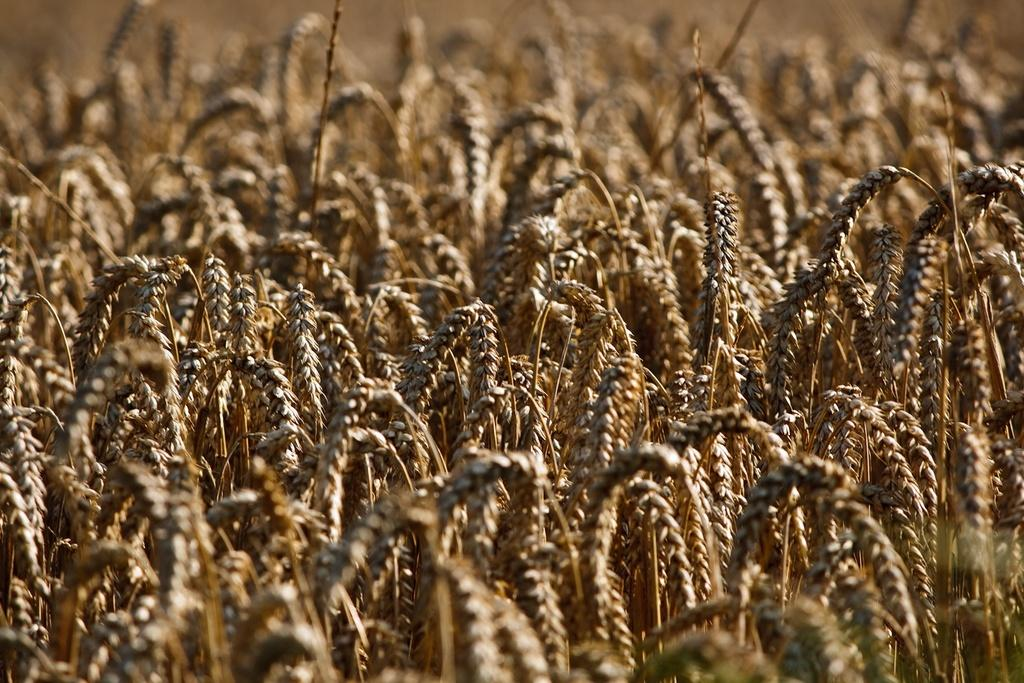What is the primary setting of the image? The image is taken in a wheat field. What type of vegetation can be seen in the image? Wheat plants can be seen in the image. Can you describe the landscape in the image? The landscape consists of a wheat field. How many wings can be seen on the dogs in the image? There are no dogs present in the image, and therefore no wings can be seen on them. 